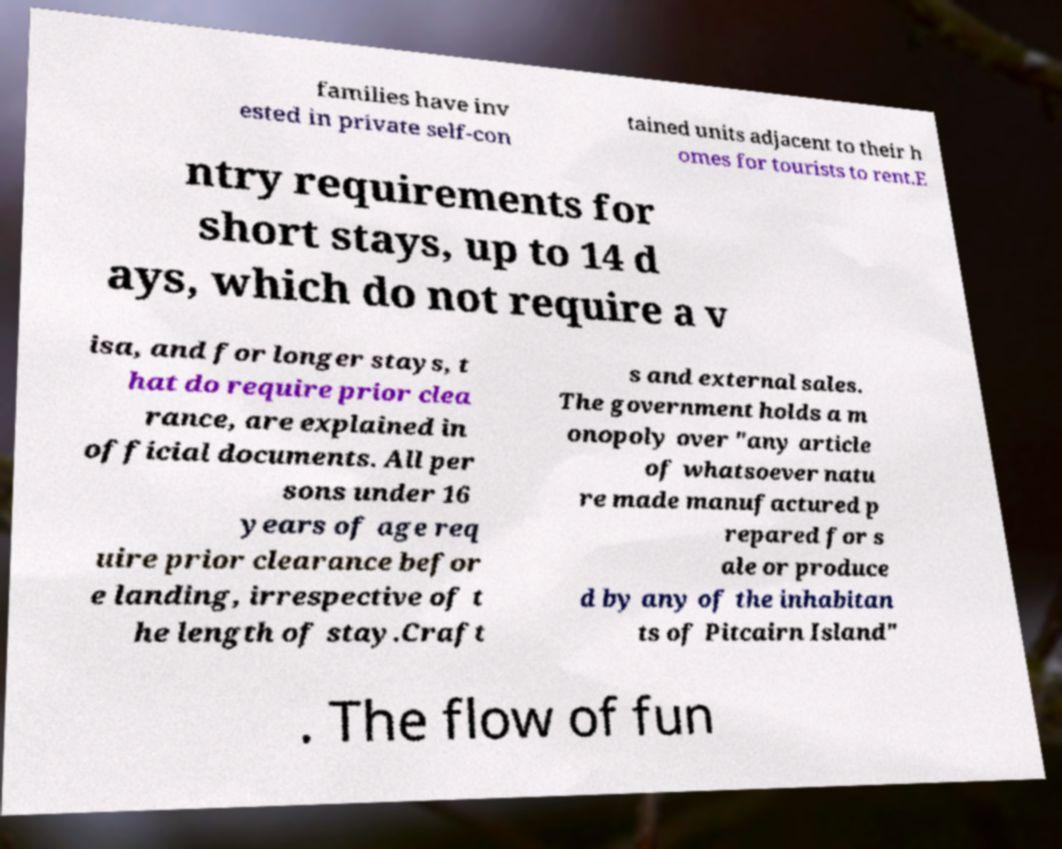Please read and relay the text visible in this image. What does it say? families have inv ested in private self-con tained units adjacent to their h omes for tourists to rent.E ntry requirements for short stays, up to 14 d ays, which do not require a v isa, and for longer stays, t hat do require prior clea rance, are explained in official documents. All per sons under 16 years of age req uire prior clearance befor e landing, irrespective of t he length of stay.Craft s and external sales. The government holds a m onopoly over "any article of whatsoever natu re made manufactured p repared for s ale or produce d by any of the inhabitan ts of Pitcairn Island" . The flow of fun 